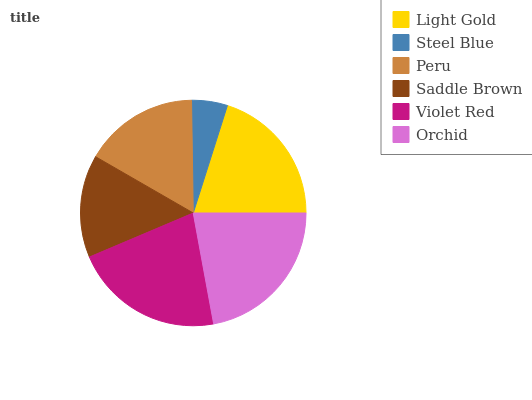Is Steel Blue the minimum?
Answer yes or no. Yes. Is Orchid the maximum?
Answer yes or no. Yes. Is Peru the minimum?
Answer yes or no. No. Is Peru the maximum?
Answer yes or no. No. Is Peru greater than Steel Blue?
Answer yes or no. Yes. Is Steel Blue less than Peru?
Answer yes or no. Yes. Is Steel Blue greater than Peru?
Answer yes or no. No. Is Peru less than Steel Blue?
Answer yes or no. No. Is Light Gold the high median?
Answer yes or no. Yes. Is Peru the low median?
Answer yes or no. Yes. Is Peru the high median?
Answer yes or no. No. Is Saddle Brown the low median?
Answer yes or no. No. 